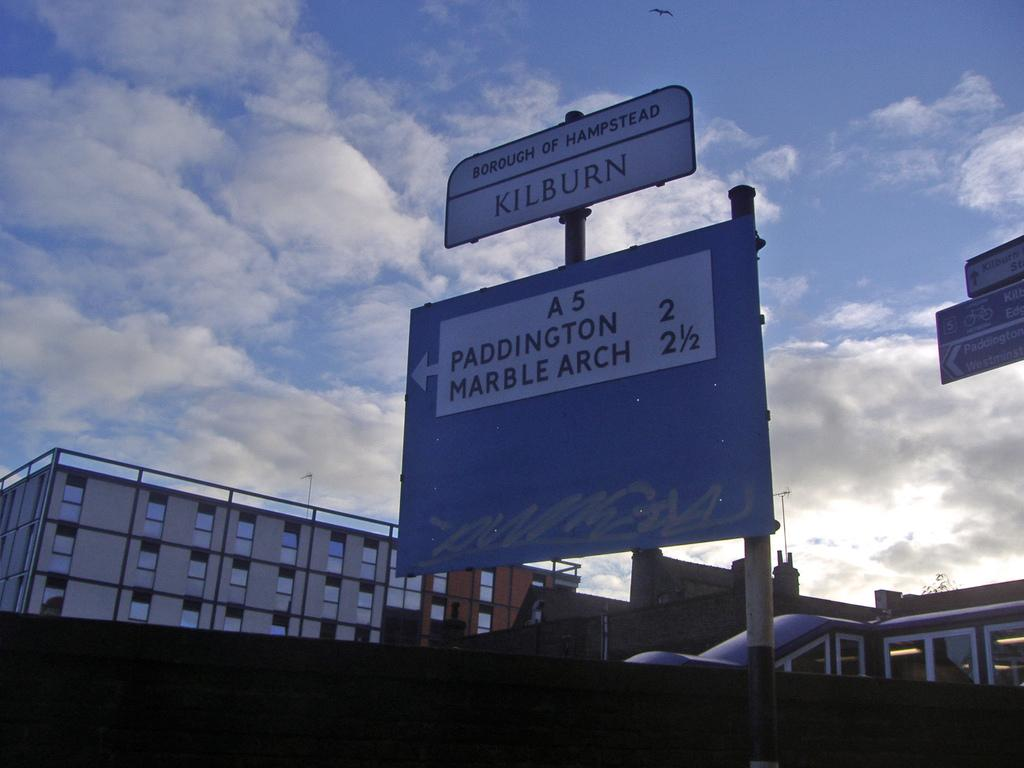<image>
Write a terse but informative summary of the picture. A borough of Hampstead Kilburn sign stating the distance away for Paddington and Marble Arch. 